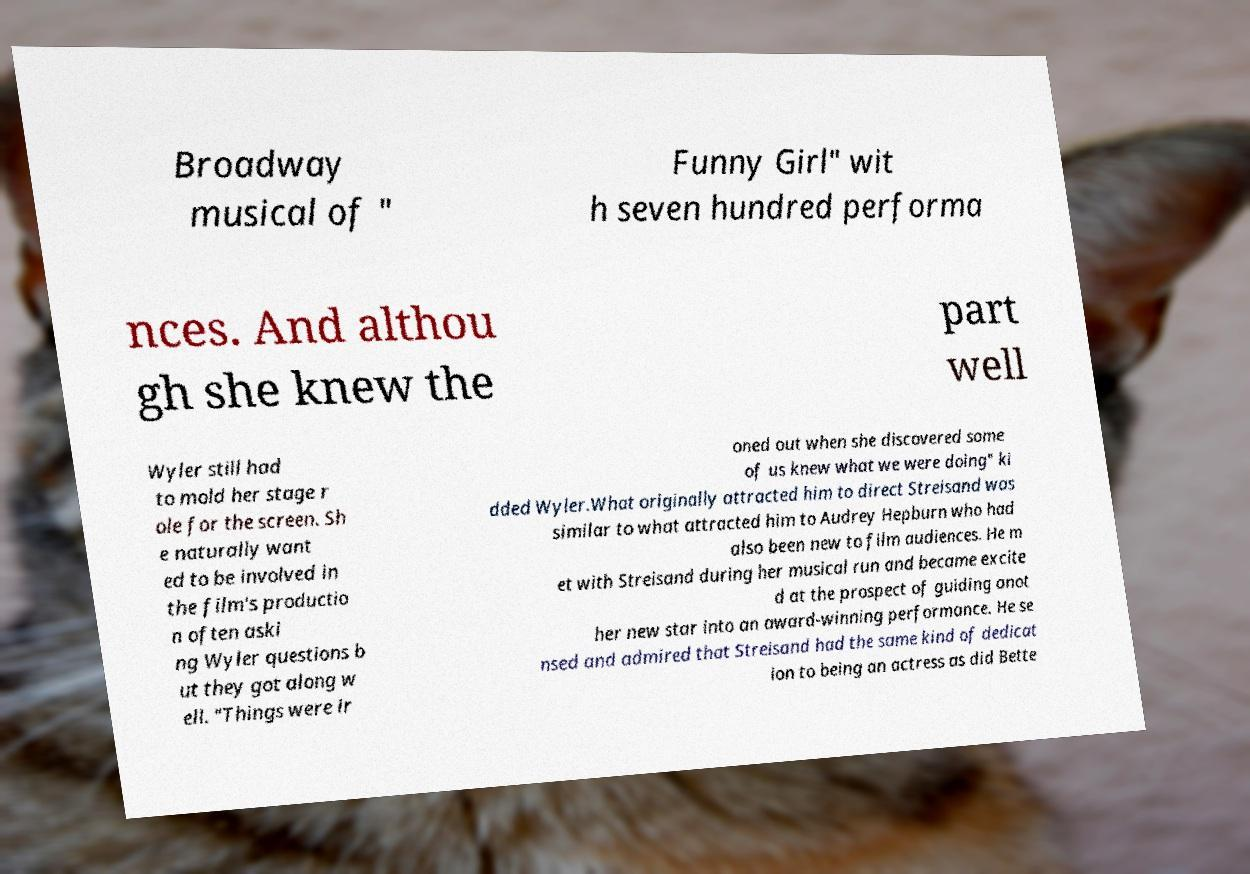Could you assist in decoding the text presented in this image and type it out clearly? Broadway musical of " Funny Girl" wit h seven hundred performa nces. And althou gh she knew the part well Wyler still had to mold her stage r ole for the screen. Sh e naturally want ed to be involved in the film's productio n often aski ng Wyler questions b ut they got along w ell. "Things were ir oned out when she discovered some of us knew what we were doing" ki dded Wyler.What originally attracted him to direct Streisand was similar to what attracted him to Audrey Hepburn who had also been new to film audiences. He m et with Streisand during her musical run and became excite d at the prospect of guiding anot her new star into an award-winning performance. He se nsed and admired that Streisand had the same kind of dedicat ion to being an actress as did Bette 